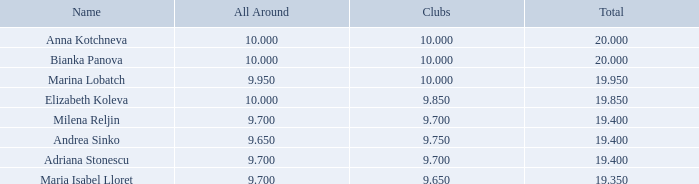How many places have bianka panova as the name, with clubs less than 10? 0.0. 